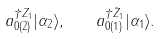Convert formula to latex. <formula><loc_0><loc_0><loc_500><loc_500>a ^ { \dagger Z _ { 1 } } _ { 0 ( 2 ) } | \alpha _ { 2 } \rangle , \quad a ^ { \dagger \bar { Z } _ { 1 } } _ { 0 ( 1 ) } | \alpha _ { 1 } \rangle .</formula> 